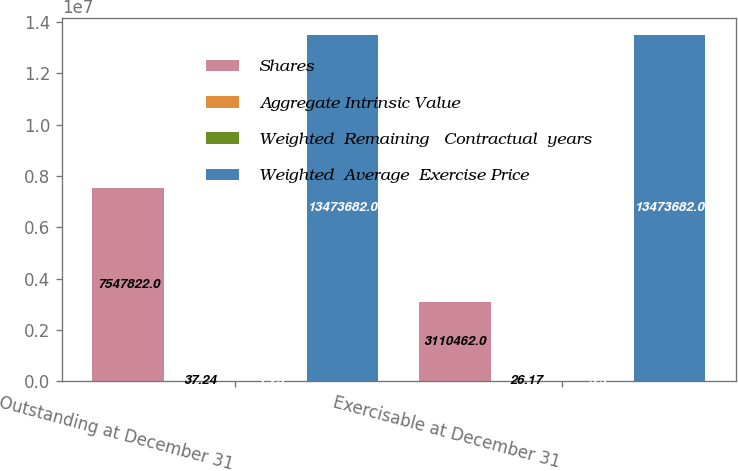<chart> <loc_0><loc_0><loc_500><loc_500><stacked_bar_chart><ecel><fcel>Outstanding at December 31<fcel>Exercisable at December 31<nl><fcel>Shares<fcel>7.54782e+06<fcel>3.11046e+06<nl><fcel>Aggregate Intrinsic Value<fcel>37.24<fcel>26.17<nl><fcel>Weighted  Remaining   Contractual  years<fcel>7.25<fcel>5.9<nl><fcel>Weighted  Average  Exercise Price<fcel>1.34737e+07<fcel>1.34737e+07<nl></chart> 